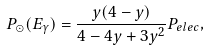Convert formula to latex. <formula><loc_0><loc_0><loc_500><loc_500>P _ { \odot } ( E _ { \gamma } ) = \frac { y ( 4 - y ) } { 4 - 4 y + 3 y ^ { 2 } } P _ { e l e c } ,</formula> 